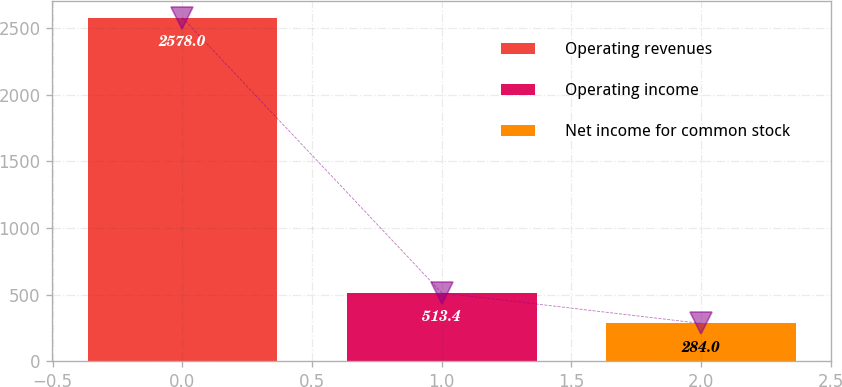Convert chart to OTSL. <chart><loc_0><loc_0><loc_500><loc_500><bar_chart><fcel>Operating revenues<fcel>Operating income<fcel>Net income for common stock<nl><fcel>2578<fcel>513.4<fcel>284<nl></chart> 